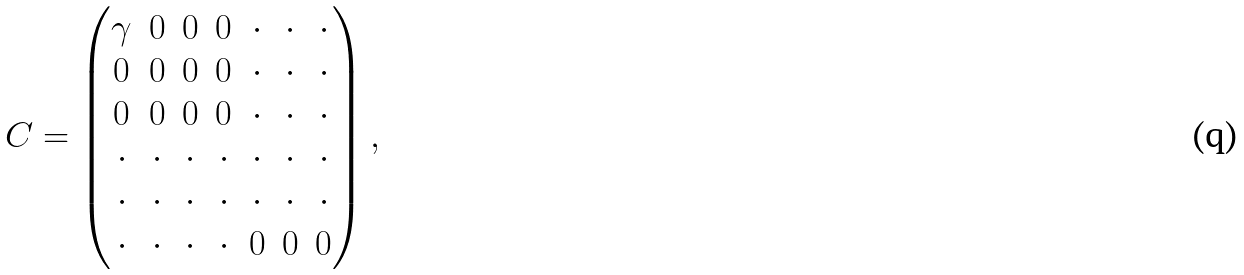Convert formula to latex. <formula><loc_0><loc_0><loc_500><loc_500>C = \begin{pmatrix} \gamma & 0 & 0 & 0 & \cdot & \cdot & \cdot \\ 0 & 0 & 0 & 0 & \cdot & \cdot & \cdot \\ 0 & 0 & 0 & 0 & \cdot & \cdot & \cdot \\ \cdot & \cdot & \cdot & \cdot & \cdot & \cdot & \cdot \\ \cdot & \cdot & \cdot & \cdot & \cdot & \cdot & \cdot \\ \cdot & \cdot & \cdot & \cdot & 0 & 0 & 0 \end{pmatrix} ,</formula> 